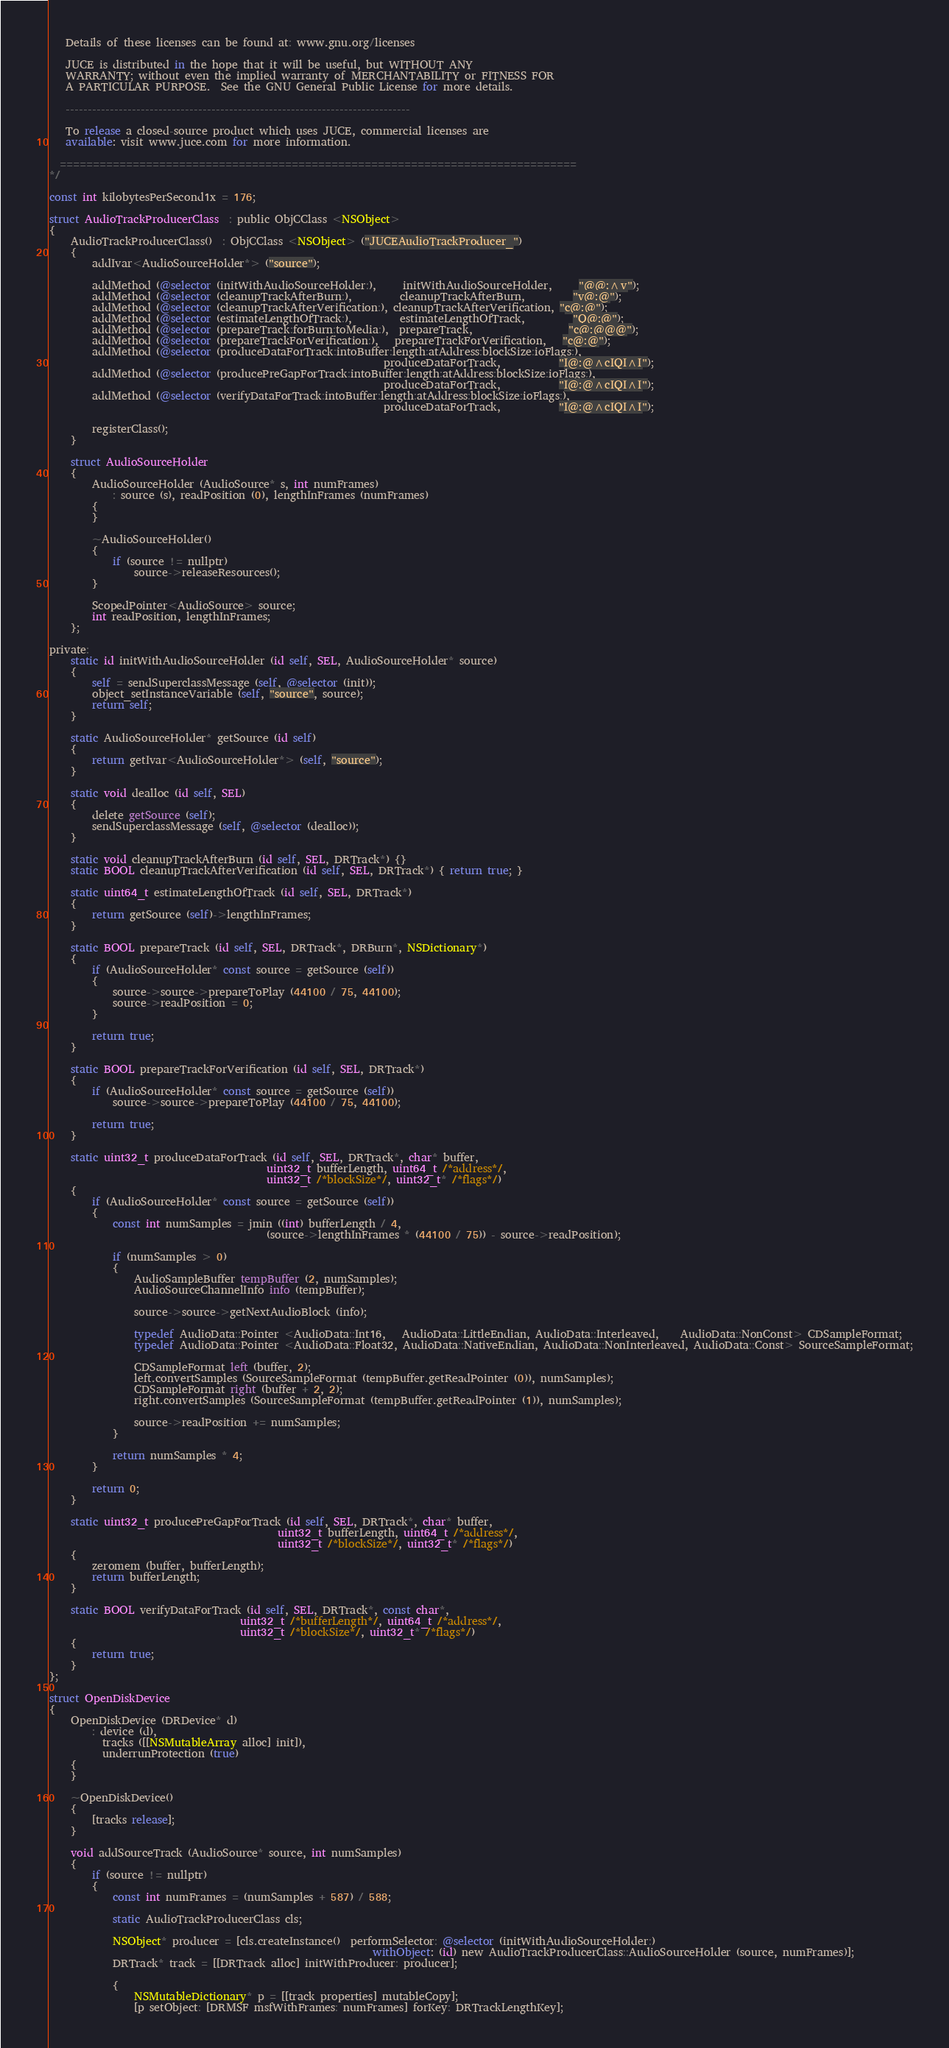<code> <loc_0><loc_0><loc_500><loc_500><_ObjectiveC_>   Details of these licenses can be found at: www.gnu.org/licenses

   JUCE is distributed in the hope that it will be useful, but WITHOUT ANY
   WARRANTY; without even the implied warranty of MERCHANTABILITY or FITNESS FOR
   A PARTICULAR PURPOSE.  See the GNU General Public License for more details.

   ------------------------------------------------------------------------------

   To release a closed-source product which uses JUCE, commercial licenses are
   available: visit www.juce.com for more information.

  ==============================================================================
*/

const int kilobytesPerSecond1x = 176;

struct AudioTrackProducerClass  : public ObjCClass <NSObject>
{
    AudioTrackProducerClass()  : ObjCClass <NSObject> ("JUCEAudioTrackProducer_")
    {
        addIvar<AudioSourceHolder*> ("source");

        addMethod (@selector (initWithAudioSourceHolder:),     initWithAudioSourceHolder,     "@@:^v");
        addMethod (@selector (cleanupTrackAfterBurn:),         cleanupTrackAfterBurn,         "v@:@");
        addMethod (@selector (cleanupTrackAfterVerification:), cleanupTrackAfterVerification, "c@:@");
        addMethod (@selector (estimateLengthOfTrack:),         estimateLengthOfTrack,         "Q@:@");
        addMethod (@selector (prepareTrack:forBurn:toMedia:),  prepareTrack,                  "c@:@@@");
        addMethod (@selector (prepareTrackForVerification:),   prepareTrackForVerification,   "c@:@");
        addMethod (@selector (produceDataForTrack:intoBuffer:length:atAddress:blockSize:ioFlags:),
                                                               produceDataForTrack,           "I@:@^cIQI^I");
        addMethod (@selector (producePreGapForTrack:intoBuffer:length:atAddress:blockSize:ioFlags:),
                                                               produceDataForTrack,           "I@:@^cIQI^I");
        addMethod (@selector (verifyDataForTrack:intoBuffer:length:atAddress:blockSize:ioFlags:),
                                                               produceDataForTrack,           "I@:@^cIQI^I");

        registerClass();
    }

    struct AudioSourceHolder
    {
        AudioSourceHolder (AudioSource* s, int numFrames)
            : source (s), readPosition (0), lengthInFrames (numFrames)
        {
        }

        ~AudioSourceHolder()
        {
            if (source != nullptr)
                source->releaseResources();
        }

        ScopedPointer<AudioSource> source;
        int readPosition, lengthInFrames;
    };

private:
    static id initWithAudioSourceHolder (id self, SEL, AudioSourceHolder* source)
    {
        self = sendSuperclassMessage (self, @selector (init));
        object_setInstanceVariable (self, "source", source);
        return self;
    }

    static AudioSourceHolder* getSource (id self)
    {
        return getIvar<AudioSourceHolder*> (self, "source");
    }

    static void dealloc (id self, SEL)
    {
        delete getSource (self);
        sendSuperclassMessage (self, @selector (dealloc));
    }

    static void cleanupTrackAfterBurn (id self, SEL, DRTrack*) {}
    static BOOL cleanupTrackAfterVerification (id self, SEL, DRTrack*) { return true; }

    static uint64_t estimateLengthOfTrack (id self, SEL, DRTrack*)
    {
        return getSource (self)->lengthInFrames;
    }

    static BOOL prepareTrack (id self, SEL, DRTrack*, DRBurn*, NSDictionary*)
    {
        if (AudioSourceHolder* const source = getSource (self))
        {
            source->source->prepareToPlay (44100 / 75, 44100);
            source->readPosition = 0;
        }

        return true;
    }

    static BOOL prepareTrackForVerification (id self, SEL, DRTrack*)
    {
        if (AudioSourceHolder* const source = getSource (self))
            source->source->prepareToPlay (44100 / 75, 44100);

        return true;
    }

    static uint32_t produceDataForTrack (id self, SEL, DRTrack*, char* buffer,
                                         uint32_t bufferLength, uint64_t /*address*/,
                                         uint32_t /*blockSize*/, uint32_t* /*flags*/)
    {
        if (AudioSourceHolder* const source = getSource (self))
        {
            const int numSamples = jmin ((int) bufferLength / 4,
                                         (source->lengthInFrames * (44100 / 75)) - source->readPosition);

            if (numSamples > 0)
            {
                AudioSampleBuffer tempBuffer (2, numSamples);
                AudioSourceChannelInfo info (tempBuffer);

                source->source->getNextAudioBlock (info);

                typedef AudioData::Pointer <AudioData::Int16,   AudioData::LittleEndian, AudioData::Interleaved,    AudioData::NonConst> CDSampleFormat;
                typedef AudioData::Pointer <AudioData::Float32, AudioData::NativeEndian, AudioData::NonInterleaved, AudioData::Const> SourceSampleFormat;

                CDSampleFormat left (buffer, 2);
                left.convertSamples (SourceSampleFormat (tempBuffer.getReadPointer (0)), numSamples);
                CDSampleFormat right (buffer + 2, 2);
                right.convertSamples (SourceSampleFormat (tempBuffer.getReadPointer (1)), numSamples);

                source->readPosition += numSamples;
            }

            return numSamples * 4;
        }

        return 0;
    }

    static uint32_t producePreGapForTrack (id self, SEL, DRTrack*, char* buffer,
                                           uint32_t bufferLength, uint64_t /*address*/,
                                           uint32_t /*blockSize*/, uint32_t* /*flags*/)
    {
        zeromem (buffer, bufferLength);
        return bufferLength;
    }

    static BOOL verifyDataForTrack (id self, SEL, DRTrack*, const char*,
                                    uint32_t /*bufferLength*/, uint64_t /*address*/,
                                    uint32_t /*blockSize*/, uint32_t* /*flags*/)
    {
        return true;
    }
};

struct OpenDiskDevice
{
    OpenDiskDevice (DRDevice* d)
        : device (d),
          tracks ([[NSMutableArray alloc] init]),
          underrunProtection (true)
    {
    }

    ~OpenDiskDevice()
    {
        [tracks release];
    }

    void addSourceTrack (AudioSource* source, int numSamples)
    {
        if (source != nullptr)
        {
            const int numFrames = (numSamples + 587) / 588;

            static AudioTrackProducerClass cls;

            NSObject* producer = [cls.createInstance()  performSelector: @selector (initWithAudioSourceHolder:)
                                                             withObject: (id) new AudioTrackProducerClass::AudioSourceHolder (source, numFrames)];
            DRTrack* track = [[DRTrack alloc] initWithProducer: producer];

            {
                NSMutableDictionary* p = [[track properties] mutableCopy];
                [p setObject: [DRMSF msfWithFrames: numFrames] forKey: DRTrackLengthKey];</code> 